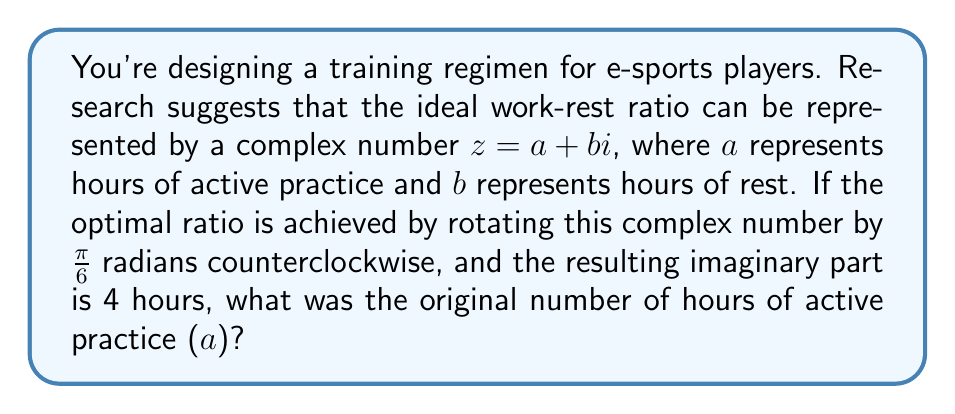Teach me how to tackle this problem. Let's approach this step-by-step:

1) The rotation of a complex number by an angle $\theta$ counterclockwise is given by multiplication with $e^{i\theta}$. In this case, $\theta = \frac{\pi}{6}$.

2) $e^{i\frac{\pi}{6}} = \cos(\frac{\pi}{6}) + i\sin(\frac{\pi}{6}) = \frac{\sqrt{3}}{2} + \frac{1}{2}i$

3) After rotation, the new complex number $z'$ is:
   $z' = z \cdot e^{i\frac{\pi}{6}} = (a+bi)(\frac{\sqrt{3}}{2} + \frac{1}{2}i)$

4) Expanding this:
   $z' = (a\frac{\sqrt{3}}{2} - b\frac{1}{2}) + (a\frac{1}{2} + b\frac{\sqrt{3}}{2})i$

5) We're told that the imaginary part of $z'$ is 4. So:
   $a\frac{1}{2} + b\frac{\sqrt{3}}{2} = 4$

6) We need to find $a$, but we don't know $b$. However, we know that $a$ and $b$ are related through the rotation. The magnitude of the complex number doesn't change after rotation, so:
   $a^2 + b^2 = (\frac{\sqrt{3}a}{2} - \frac{b}{2})^2 + (4)^2$

7) Expanding this:
   $a^2 + b^2 = \frac{3a^2}{4} + \frac{b^2}{4} - \frac{\sqrt{3}ab}{2} + 16$

8) Simplifying:
   $\frac{a^2}{4} + \frac{3b^2}{4} = 16 + \frac{\sqrt{3}ab}{2}$

9) From step 5, we can express $b$ in terms of $a$:
   $b = \frac{8-a}{\sqrt{3}}$

10) Substituting this into the equation from step 8:
    $\frac{a^2}{4} + \frac{3(64-16a+a^2)}{12} = 16 + \frac{a(8-a)}{2}$

11) Simplifying and solving this equation gives:
    $a = 4\sqrt{3}$

Therefore, the original number of hours of active practice was $4\sqrt{3}$.
Answer: $4\sqrt{3}$ hours 